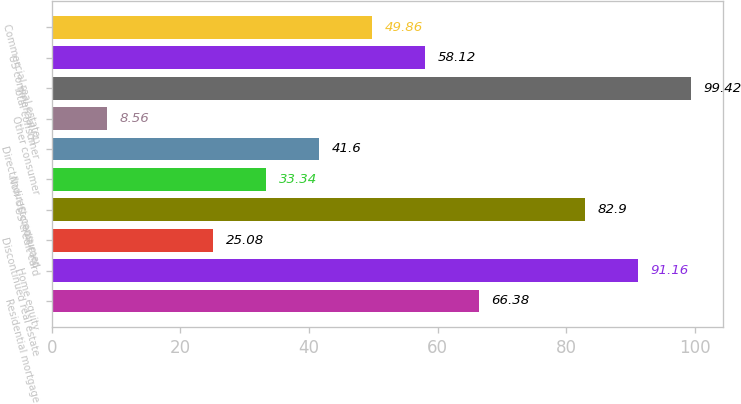Convert chart. <chart><loc_0><loc_0><loc_500><loc_500><bar_chart><fcel>Residential mortgage<fcel>Home equity<fcel>Discontinued real estate<fcel>US credit card<fcel>Non-US credit card<fcel>Direct/Indirect consumer<fcel>Other consumer<fcel>Total consumer<fcel>US commercial (4)<fcel>Commercial real estate<nl><fcel>66.38<fcel>91.16<fcel>25.08<fcel>82.9<fcel>33.34<fcel>41.6<fcel>8.56<fcel>99.42<fcel>58.12<fcel>49.86<nl></chart> 